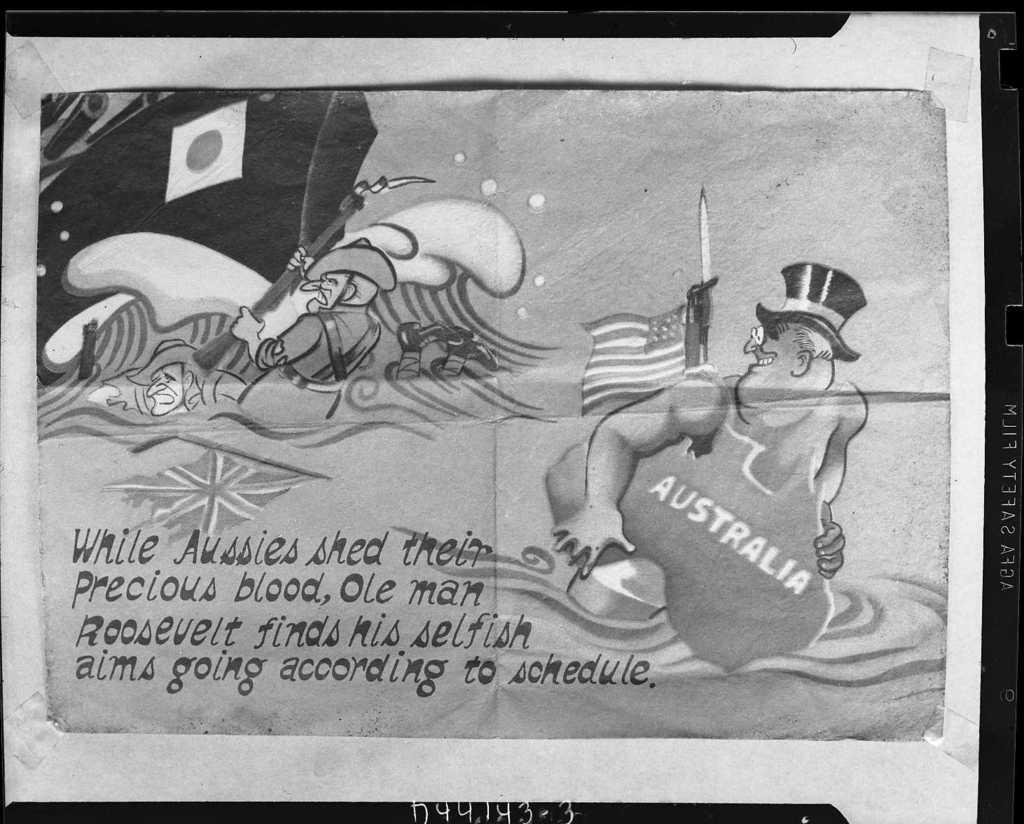Describe this image in one or two sentences. This is a black and white pic and it is attached with plasters on a platform and in the image we can see animated persons, boat on the water, flags, gun, texts written on the image and other objects. 